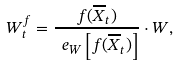Convert formula to latex. <formula><loc_0><loc_0><loc_500><loc_500>W ^ { f } _ { t } = \frac { f ( \overline { X } _ { t } ) } { \ e _ { W } \left [ f ( \overline { X } _ { t } ) \right ] } \cdot W ,</formula> 